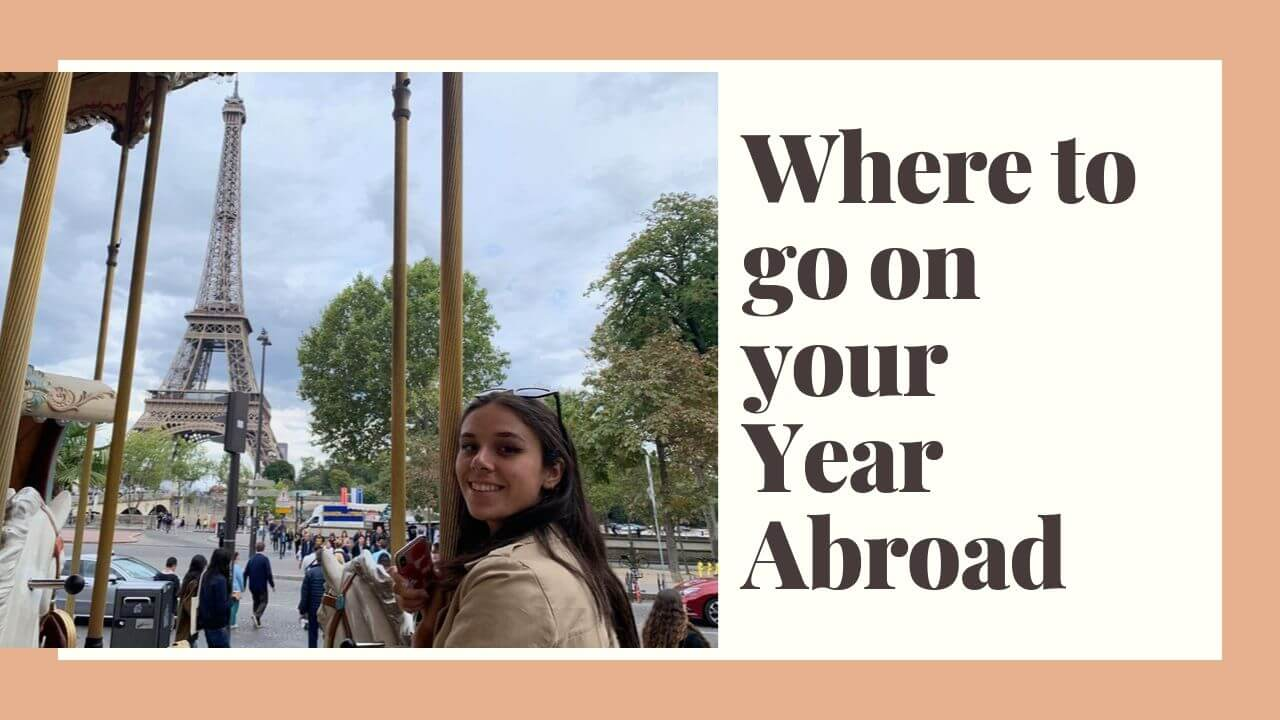What emotions do you think the image is trying to evoke in viewers? The image aims to evoke a sense of excitement, adventure, and joy. The smiling woman on the carousel combined with the view of the Eiffel Tower creates an inviting atmosphere that suggests fun and memorable experiences, appealing to those looking for an adventurous journey abroad. 